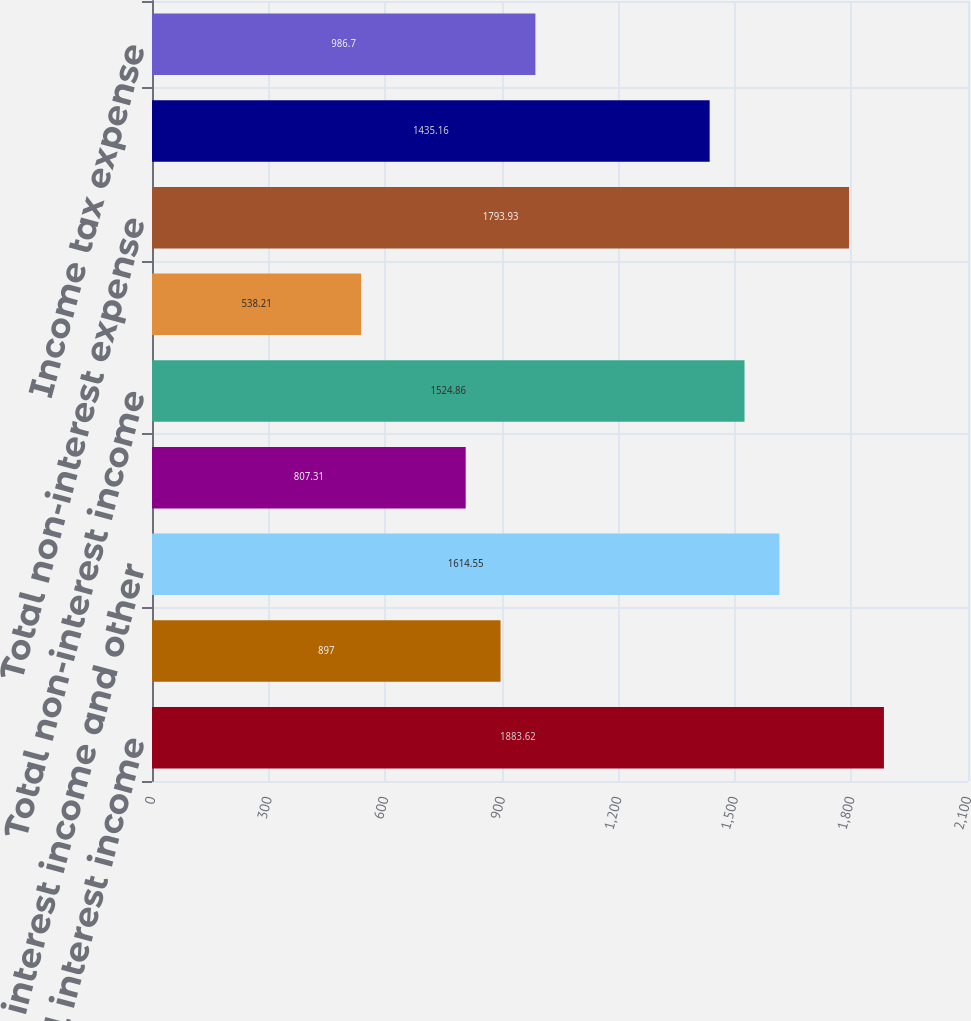<chart> <loc_0><loc_0><loc_500><loc_500><bar_chart><fcel>Total interest income<fcel>Total interest expense and<fcel>Net interest income and other<fcel>Provision for loan losses<fcel>Total non-interest income<fcel>Securities gains net<fcel>Total non-interest expense<fcel>Income from continuing<fcel>Income tax expense<nl><fcel>1883.62<fcel>897<fcel>1614.55<fcel>807.31<fcel>1524.86<fcel>538.21<fcel>1793.93<fcel>1435.16<fcel>986.7<nl></chart> 